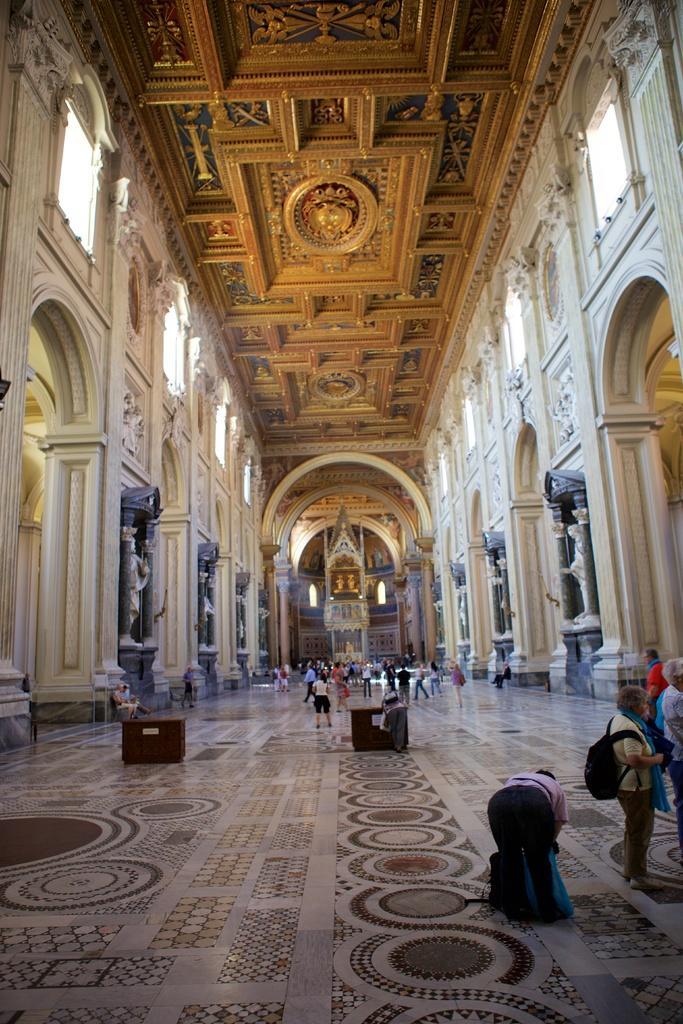Please provide a concise description of this image. In this image, we can see people inside in the building and there are some tables. At the bottom, there is floor. 